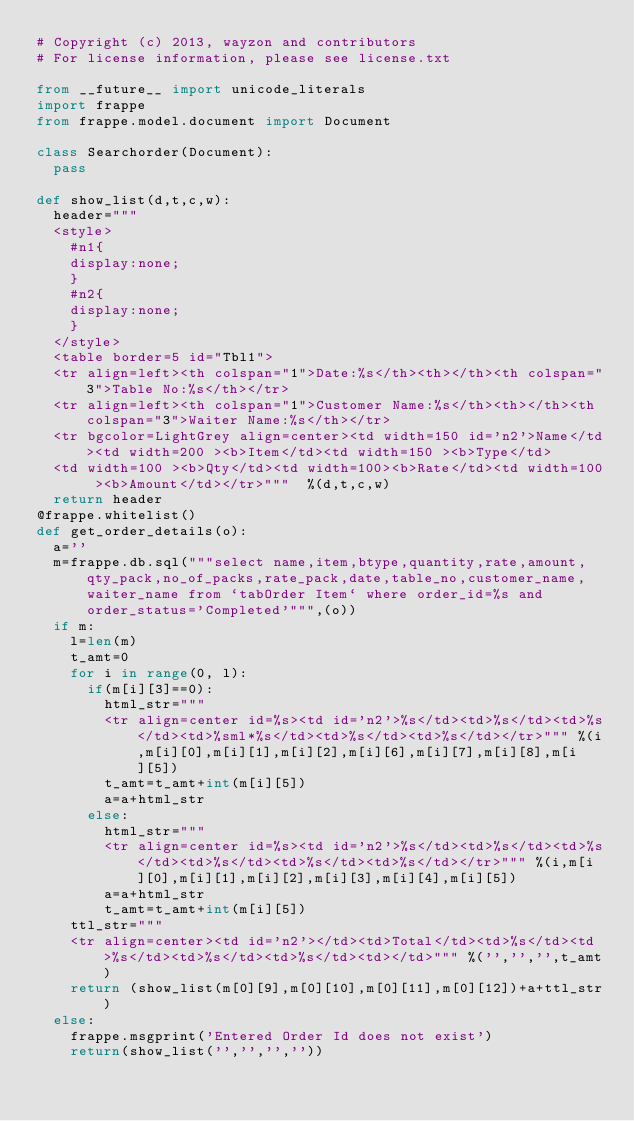Convert code to text. <code><loc_0><loc_0><loc_500><loc_500><_Python_># Copyright (c) 2013, wayzon and contributors
# For license information, please see license.txt

from __future__ import unicode_literals
import frappe
from frappe.model.document import Document

class Searchorder(Document):
	pass

def show_list(d,t,c,w):
	header="""
	<style>
		#n1{
		display:none;
		}
		#n2{
		display:none;
		}
	</style>
	<table border=5 id="Tbl1">
	<tr align=left><th colspan="1">Date:%s</th><th></th><th colspan="3">Table No:%s</th></tr>
	<tr align=left><th colspan="1">Customer Name:%s</th><th></th><th colspan="3">Waiter Name:%s</th></tr>
	<tr bgcolor=LightGrey align=center><td width=150 id='n2'>Name</td><td width=200 ><b>Item</td><td width=150 ><b>Type</td>
	<td width=100 ><b>Qty</td><td width=100><b>Rate</td><td width=100 ><b>Amount</td></tr>"""  %(d,t,c,w)
	return header
@frappe.whitelist()
def get_order_details(o):
	a=''
	m=frappe.db.sql("""select name,item,btype,quantity,rate,amount,qty_pack,no_of_packs,rate_pack,date,table_no,customer_name,waiter_name from `tabOrder Item` where order_id=%s and order_status='Completed'""",(o))
	if m:
		l=len(m)
		t_amt=0
		for i in range(0, l):
			if(m[i][3]==0):
				html_str="""
				<tr align=center id=%s><td id='n2'>%s</td><td>%s</td><td>%s</td><td>%sml*%s</td><td>%s</td><td>%s</td></tr>""" %(i,m[i][0],m[i][1],m[i][2],m[i][6],m[i][7],m[i][8],m[i][5])
				t_amt=t_amt+int(m[i][5])
				a=a+html_str
			else:
				html_str="""
				<tr align=center id=%s><td id='n2'>%s</td><td>%s</td><td>%s</td><td>%s</td><td>%s</td><td>%s</td></tr>""" %(i,m[i][0],m[i][1],m[i][2],m[i][3],m[i][4],m[i][5])
				a=a+html_str
				t_amt=t_amt+int(m[i][5])
		ttl_str="""
		<tr align=center><td id='n2'></td><td>Total</td><td>%s</td><td>%s</td><td>%s</td><td>%s</td><td></td>""" %('','','',t_amt)
		return (show_list(m[0][9],m[0][10],m[0][11],m[0][12])+a+ttl_str)
	else:
		frappe.msgprint('Entered Order Id does not exist')
		return(show_list('','','',''))</code> 